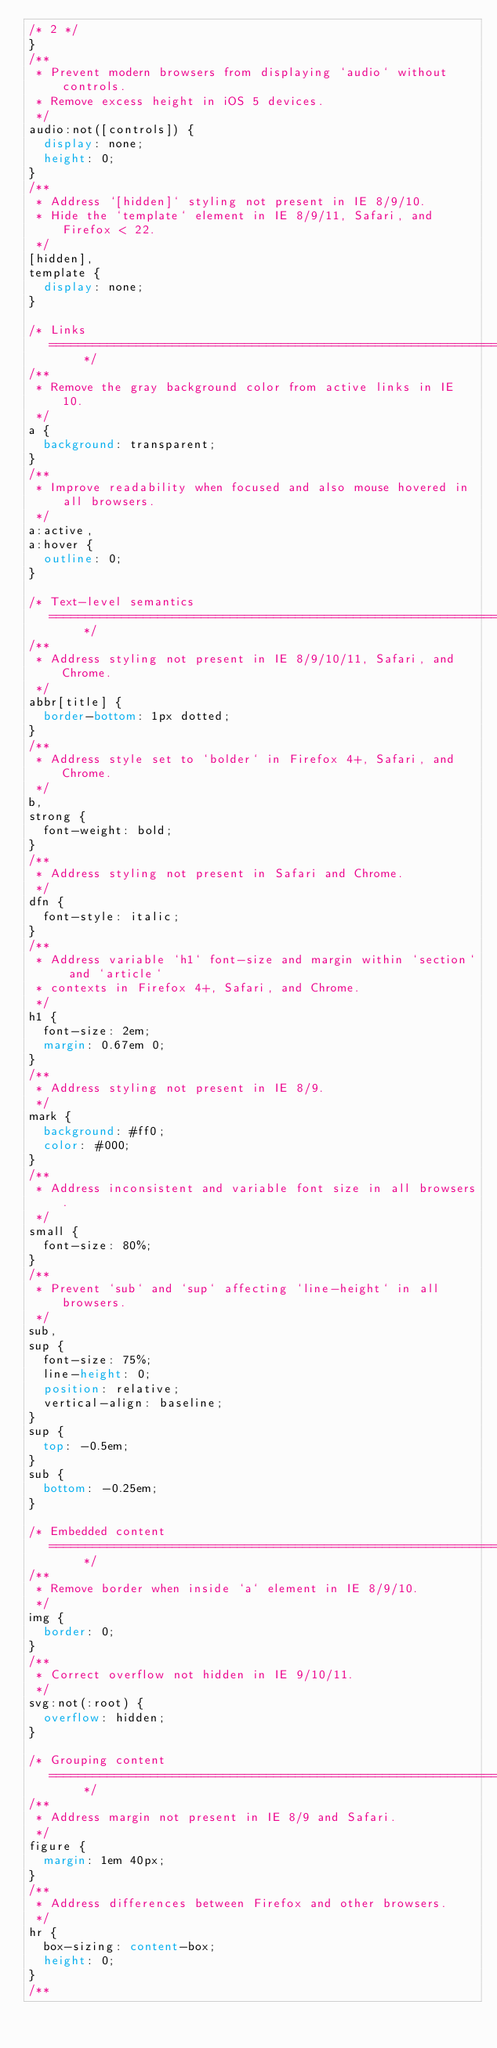<code> <loc_0><loc_0><loc_500><loc_500><_CSS_>/* 2 */
}
/**
 * Prevent modern browsers from displaying `audio` without controls.
 * Remove excess height in iOS 5 devices.
 */
audio:not([controls]) {
  display: none;
  height: 0;
}
/**
 * Address `[hidden]` styling not present in IE 8/9/10.
 * Hide the `template` element in IE 8/9/11, Safari, and Firefox < 22.
 */
[hidden],
template {
  display: none;
}

/* Links
   ========================================================================== */
/**
 * Remove the gray background color from active links in IE 10.
 */
a {
  background: transparent;
}
/**
 * Improve readability when focused and also mouse hovered in all browsers.
 */
a:active,
a:hover {
  outline: 0;
}

/* Text-level semantics
   ========================================================================== */
/**
 * Address styling not present in IE 8/9/10/11, Safari, and Chrome.
 */
abbr[title] {
  border-bottom: 1px dotted;
}
/**
 * Address style set to `bolder` in Firefox 4+, Safari, and Chrome.
 */
b,
strong {
  font-weight: bold;
}
/**
 * Address styling not present in Safari and Chrome.
 */
dfn {
  font-style: italic;
}
/**
 * Address variable `h1` font-size and margin within `section` and `article`
 * contexts in Firefox 4+, Safari, and Chrome.
 */
h1 {
  font-size: 2em;
  margin: 0.67em 0;
}
/**
 * Address styling not present in IE 8/9.
 */
mark {
  background: #ff0;
  color: #000;
}
/**
 * Address inconsistent and variable font size in all browsers.
 */
small {
  font-size: 80%;
}
/**
 * Prevent `sub` and `sup` affecting `line-height` in all browsers.
 */
sub,
sup {
  font-size: 75%;
  line-height: 0;
  position: relative;
  vertical-align: baseline;
}
sup {
  top: -0.5em;
}
sub {
  bottom: -0.25em;
}

/* Embedded content
   ========================================================================== */
/**
 * Remove border when inside `a` element in IE 8/9/10.
 */
img {
  border: 0;
}
/**
 * Correct overflow not hidden in IE 9/10/11.
 */
svg:not(:root) {
  overflow: hidden;
}

/* Grouping content
   ========================================================================== */
/**
 * Address margin not present in IE 8/9 and Safari.
 */
figure {
  margin: 1em 40px;
}
/**
 * Address differences between Firefox and other browsers.
 */
hr {
  box-sizing: content-box;
  height: 0;
}
/**</code> 